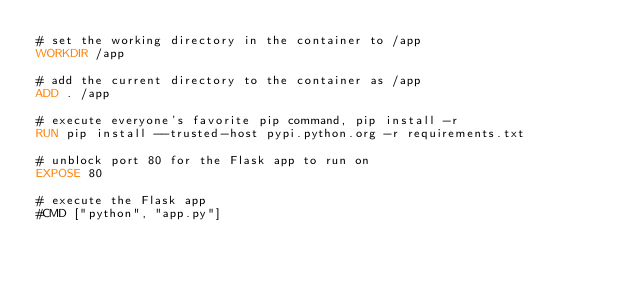<code> <loc_0><loc_0><loc_500><loc_500><_Dockerfile_># set the working directory in the container to /app
WORKDIR /app

# add the current directory to the container as /app
ADD . /app

# execute everyone's favorite pip command, pip install -r
RUN pip install --trusted-host pypi.python.org -r requirements.txt

# unblock port 80 for the Flask app to run on
EXPOSE 80

# execute the Flask app
#CMD ["python", "app.py"]
</code> 